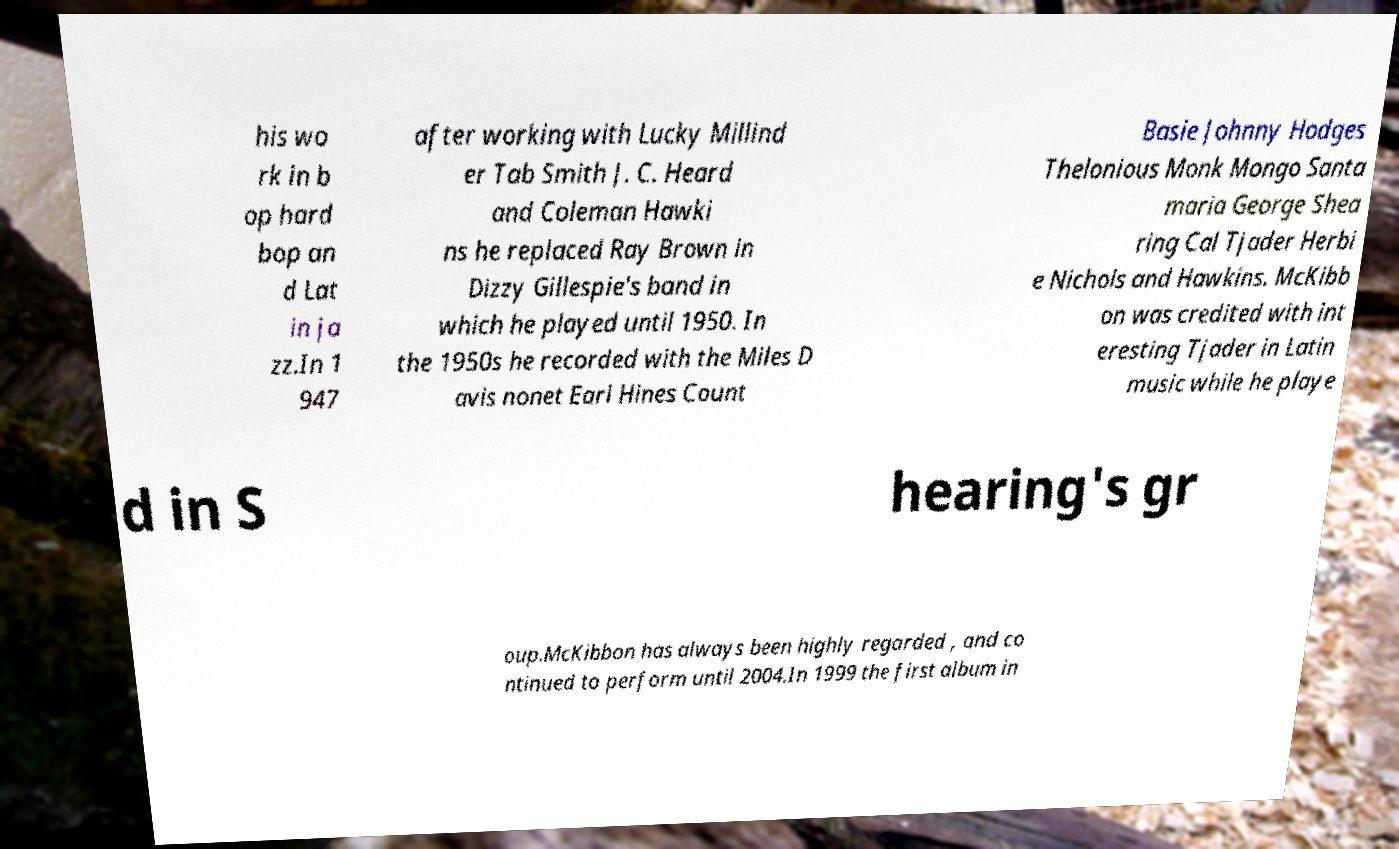Can you read and provide the text displayed in the image?This photo seems to have some interesting text. Can you extract and type it out for me? his wo rk in b op hard bop an d Lat in ja zz.In 1 947 after working with Lucky Millind er Tab Smith J. C. Heard and Coleman Hawki ns he replaced Ray Brown in Dizzy Gillespie's band in which he played until 1950. In the 1950s he recorded with the Miles D avis nonet Earl Hines Count Basie Johnny Hodges Thelonious Monk Mongo Santa maria George Shea ring Cal Tjader Herbi e Nichols and Hawkins. McKibb on was credited with int eresting Tjader in Latin music while he playe d in S hearing's gr oup.McKibbon has always been highly regarded , and co ntinued to perform until 2004.In 1999 the first album in 